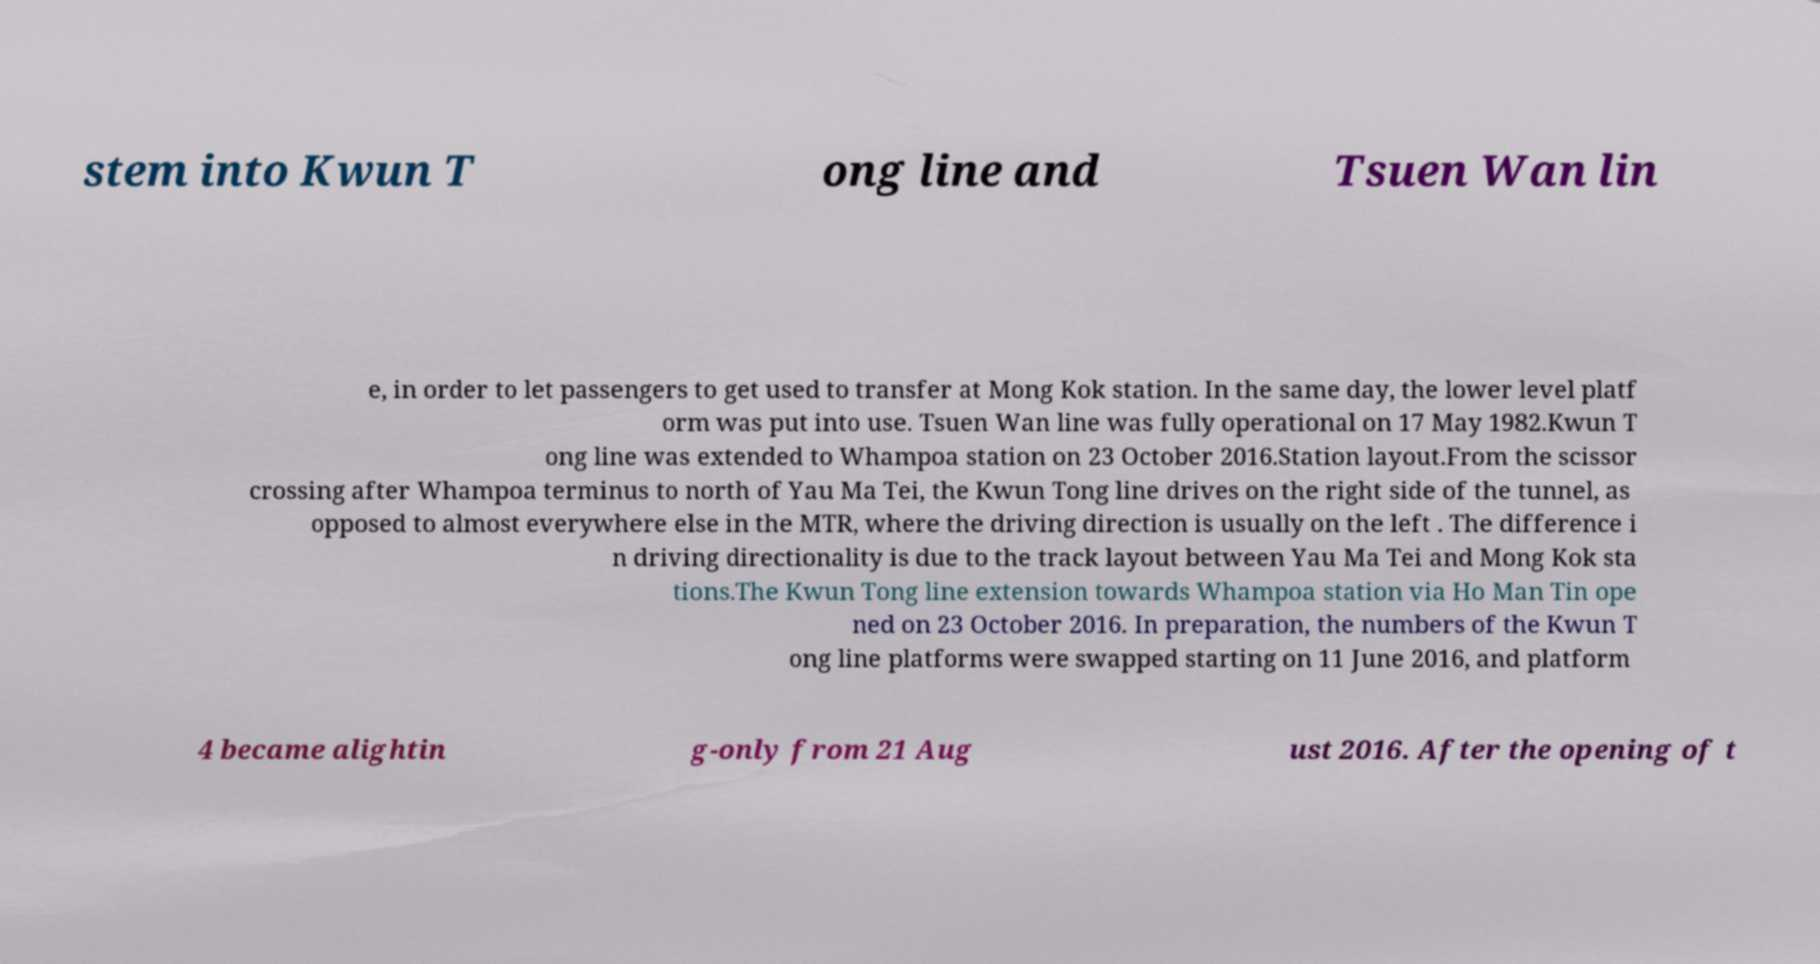Can you accurately transcribe the text from the provided image for me? stem into Kwun T ong line and Tsuen Wan lin e, in order to let passengers to get used to transfer at Mong Kok station. In the same day, the lower level platf orm was put into use. Tsuen Wan line was fully operational on 17 May 1982.Kwun T ong line was extended to Whampoa station on 23 October 2016.Station layout.From the scissor crossing after Whampoa terminus to north of Yau Ma Tei, the Kwun Tong line drives on the right side of the tunnel, as opposed to almost everywhere else in the MTR, where the driving direction is usually on the left . The difference i n driving directionality is due to the track layout between Yau Ma Tei and Mong Kok sta tions.The Kwun Tong line extension towards Whampoa station via Ho Man Tin ope ned on 23 October 2016. In preparation, the numbers of the Kwun T ong line platforms were swapped starting on 11 June 2016, and platform 4 became alightin g-only from 21 Aug ust 2016. After the opening of t 